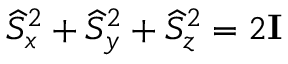Convert formula to latex. <formula><loc_0><loc_0><loc_500><loc_500>\widehat { S } _ { x } ^ { 2 } + \widehat { S } _ { y } ^ { 2 } + \widehat { S } _ { z } ^ { 2 } = 2 I</formula> 